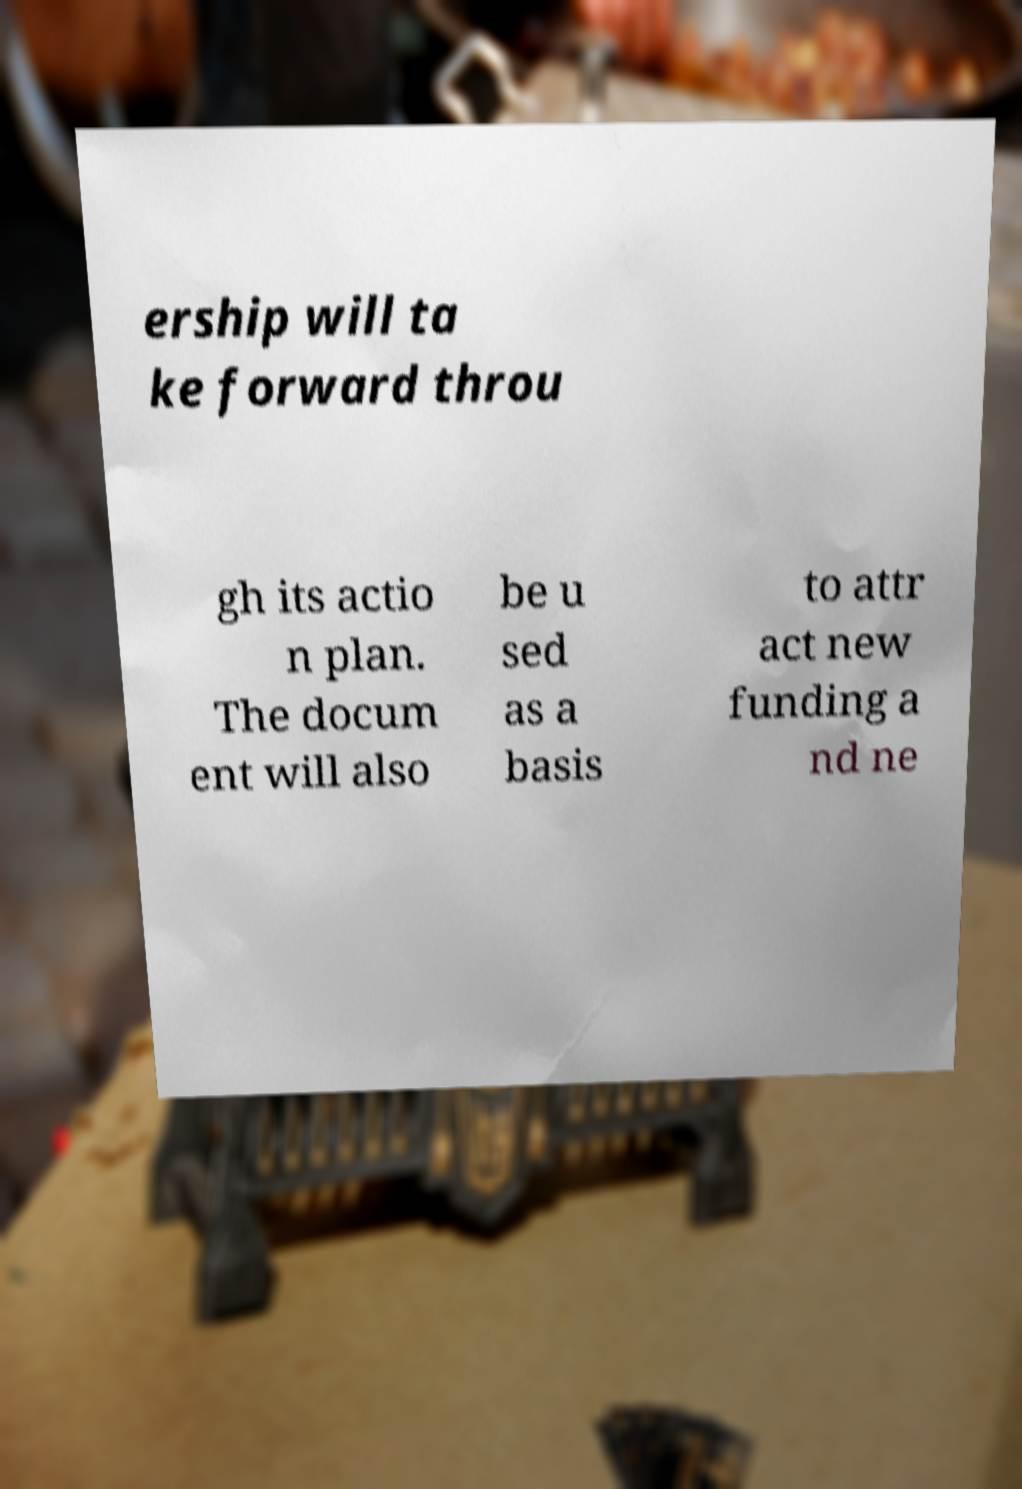There's text embedded in this image that I need extracted. Can you transcribe it verbatim? ership will ta ke forward throu gh its actio n plan. The docum ent will also be u sed as a basis to attr act new funding a nd ne 